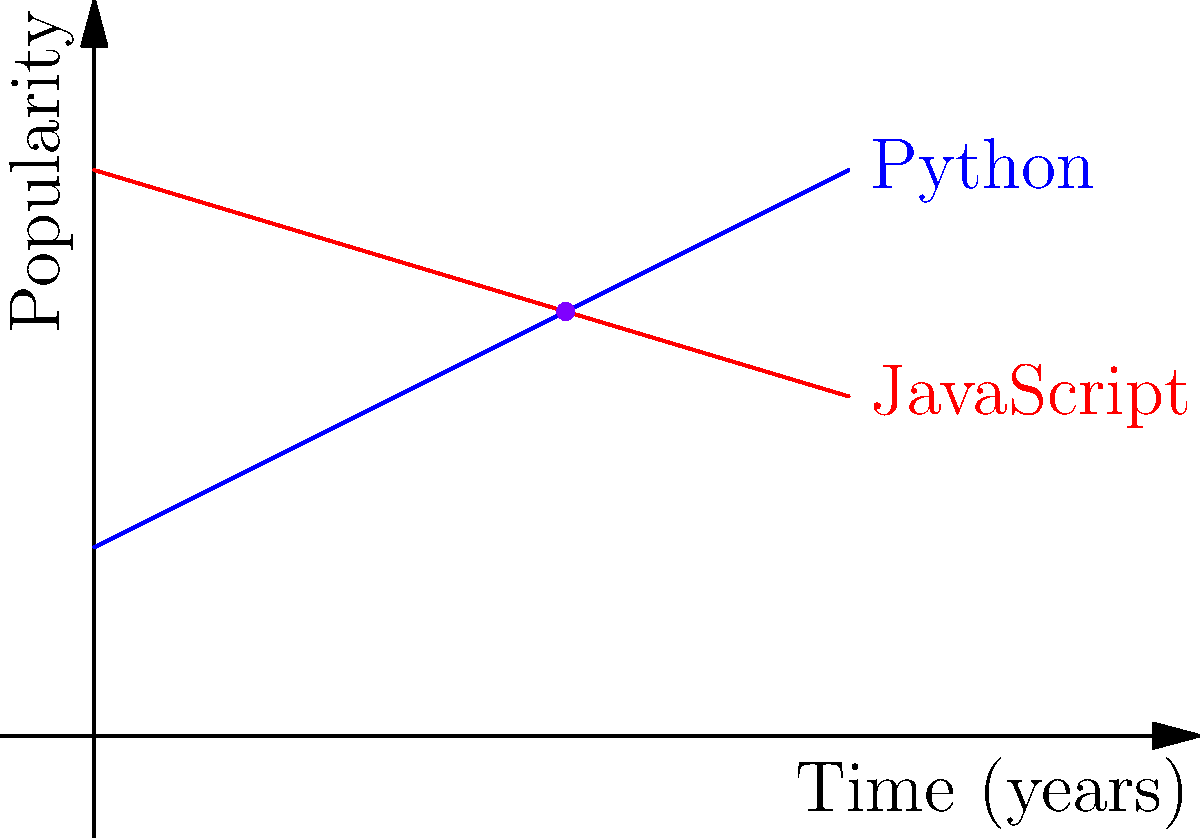As a successful app developer, you're analyzing programming language trends. The graph shows the popularity of Python and JavaScript over time. If the lines represent linear equations, what is the angle (in degrees) between these two trend lines? To find the angle between two intersecting lines, we can use the following steps:

1. Identify the slopes of both lines:
   Python (blue): $m_1 = 0.5$
   JavaScript (red): $m_2 = -0.3$

2. Use the formula for the angle between two lines:
   $\tan \theta = |\frac{m_1 - m_2}{1 + m_1m_2}|$

3. Substitute the values:
   $\tan \theta = |\frac{0.5 - (-0.3)}{1 + (0.5)(-0.3)}|$

4. Simplify:
   $\tan \theta = |\frac{0.8}{0.85}| \approx 0.9412$

5. Take the inverse tangent (arctangent) to find the angle:
   $\theta = \tan^{-1}(0.9412)$

6. Convert to degrees:
   $\theta \approx 43.3°$

Therefore, the angle between the two trend lines is approximately 43.3 degrees.
Answer: $43.3°$ 